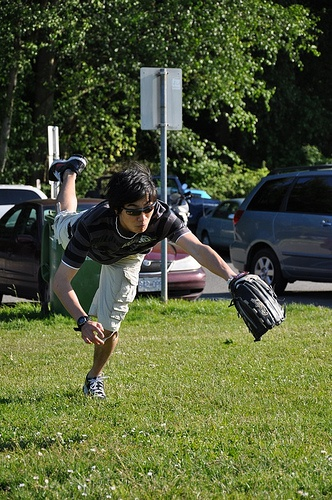Describe the objects in this image and their specific colors. I can see people in darkgreen, black, gray, lightgray, and darkgray tones, car in darkgreen, black, navy, gray, and darkblue tones, car in darkgreen, black, gray, white, and darkgray tones, baseball glove in darkgreen, black, lightgray, gray, and darkgray tones, and backpack in darkgreen, black, lightgray, gray, and darkgray tones in this image. 